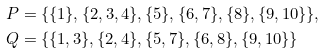Convert formula to latex. <formula><loc_0><loc_0><loc_500><loc_500>P & = \{ \{ 1 \} , \{ 2 , 3 , 4 \} , \{ 5 \} , \{ 6 , 7 \} , \{ 8 \} , \{ 9 , 1 0 \} \} , \\ Q & = \{ \{ 1 , 3 \} , \{ 2 , 4 \} , \{ 5 , 7 \} , \{ 6 , 8 \} , \{ 9 , 1 0 \} \}</formula> 